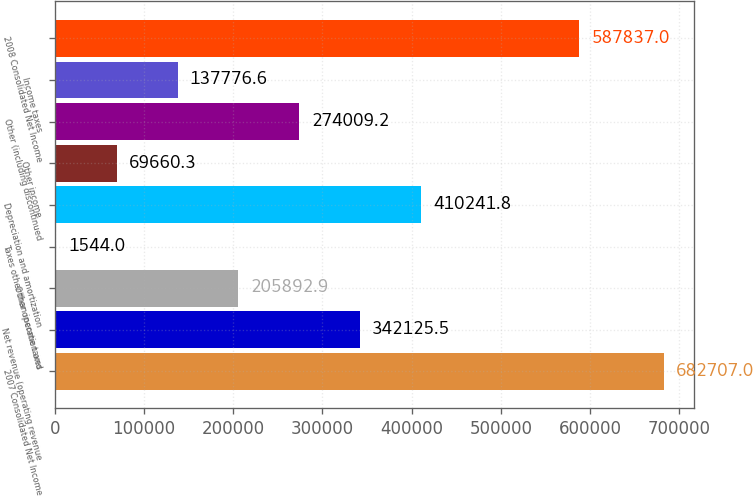<chart> <loc_0><loc_0><loc_500><loc_500><bar_chart><fcel>2007 Consolidated Net Income<fcel>Net revenue (operating revenue<fcel>Other operation and<fcel>Taxes other than income taxes<fcel>Depreciation and amortization<fcel>Other income<fcel>Other (including discontinued<fcel>Income taxes<fcel>2008 Consolidated Net Income<nl><fcel>682707<fcel>342126<fcel>205893<fcel>1544<fcel>410242<fcel>69660.3<fcel>274009<fcel>137777<fcel>587837<nl></chart> 